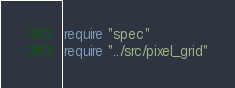<code> <loc_0><loc_0><loc_500><loc_500><_Crystal_>require "spec"
require "../src/pixel_grid"
</code> 